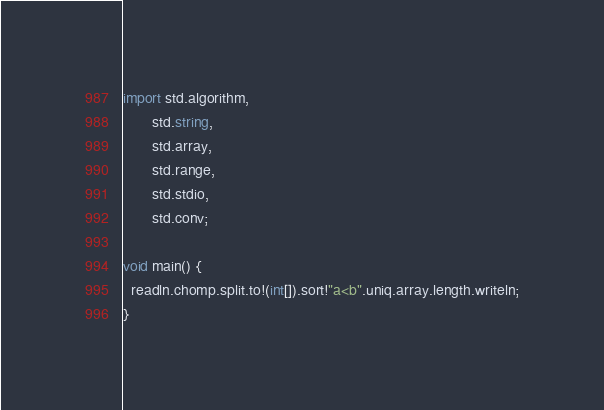<code> <loc_0><loc_0><loc_500><loc_500><_D_>import std.algorithm,
       std.string,
       std.array,
       std.range,
       std.stdio,
       std.conv;

void main() {
  readln.chomp.split.to!(int[]).sort!"a<b".uniq.array.length.writeln;
}
</code> 